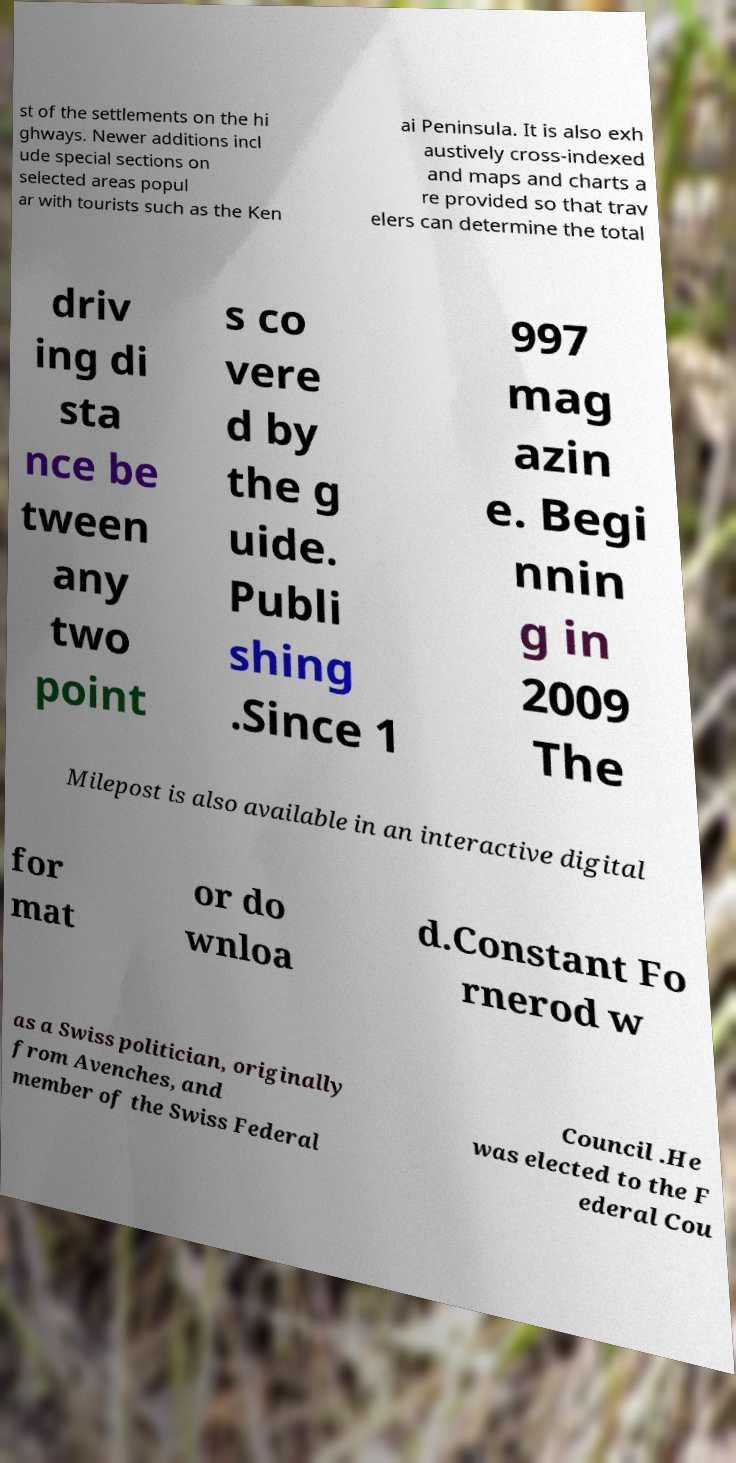Please identify and transcribe the text found in this image. st of the settlements on the hi ghways. Newer additions incl ude special sections on selected areas popul ar with tourists such as the Ken ai Peninsula. It is also exh austively cross-indexed and maps and charts a re provided so that trav elers can determine the total driv ing di sta nce be tween any two point s co vere d by the g uide. Publi shing .Since 1 997 mag azin e. Begi nnin g in 2009 The Milepost is also available in an interactive digital for mat or do wnloa d.Constant Fo rnerod w as a Swiss politician, originally from Avenches, and member of the Swiss Federal Council .He was elected to the F ederal Cou 